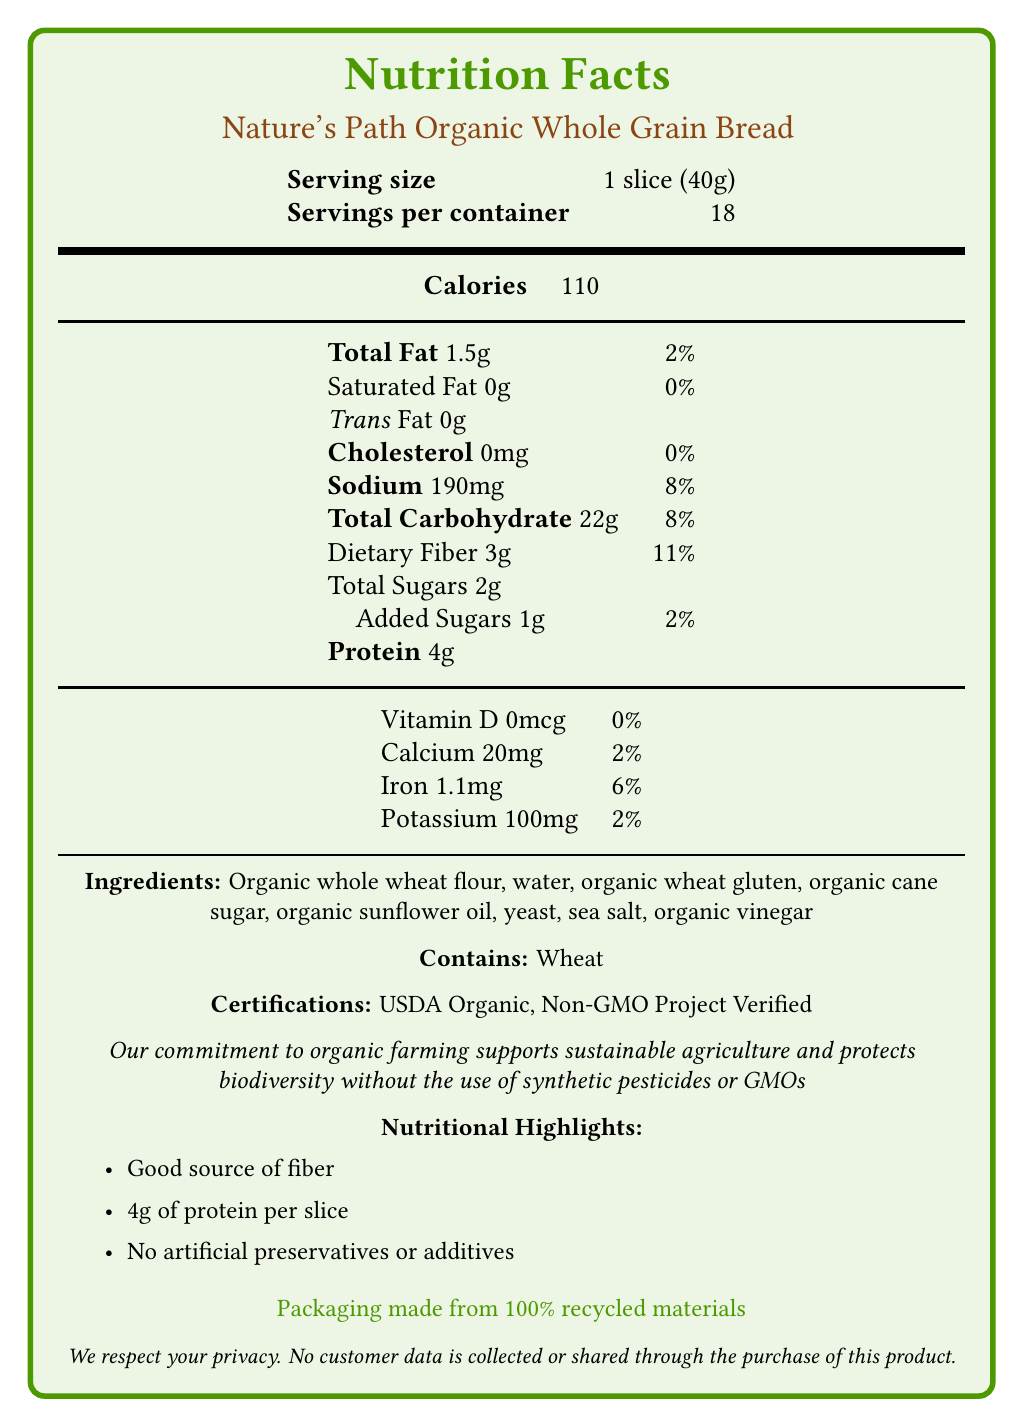what is the serving size? The serving size is listed as "1 slice (40g)" in the document.
Answer: 1 slice (40g) how much dietary fiber is in one slice? The document specifies that there are 3g of dietary fiber per serving.
Answer: 3g what percentage of the daily value of dietary fiber does one slice provide? The nutritional information indicates that one slice provides 11% of the daily value for dietary fiber.
Answer: 11% how many grams of protein are in one slice? The document states that one slice contains 4 grams of protein.
Answer: 4g what certifications does this bread have? The certifications listed in the document are USDA Organic and Non-GMO Project Verified.
Answer: USDA Organic, Non-GMO Project Verified is there any added sugar in the bread? The bread contains 1g of added sugars according to the nutritional information.
Answer: Yes does this bread contain any artificial preservatives or additives? The document highlights that the bread contains no artificial preservatives or additives.
Answer: No what is the total carbohydrate content per serving? A. 15g B. 20g C. 22g D. 25g The document lists the total carbohydrate content per serving as 22g.
Answer: C. 22g which of the following is NOT an ingredient in the bread? A. Organic whole wheat flour B. Organic cane sugar C. Organic almond flour D. Organic sunflower oil The ingredients listed do not include organic almond flour.
Answer: C. Organic almond flour does the bread contain any allergens? The document states that the bread contains wheat, which is an allergen.
Answer: Yes describe the main idea of the document The document presents the nutritional information for Nature's Path Organic Whole Grain Bread, including serving size, calories, macronutrient content, certifications, and other relevant details.
Answer: Nutrition facts for Nature's Path Organic Whole Grain Bread what is the environmental impact of the bread's packaging? The document indicates that the bread's packaging is made from 100% recycled materials.
Answer: Packaging made from 100% recycled materials how is the bread meant to be stored for maximum freshness? The storage instructions advise to keep the bread refrigerated and consume it within 7 days of opening.
Answer: Keep refrigerated and consume within 7 days of opening what organization manufactures this bread? The manufacturer of the bread is Nature's Path Foods, as stated in the document.
Answer: Nature's Path Foods how much calcium does one slice provide? The nutritional information lists the calcium content as 20mg per slice.
Answer: 20mg how many servings are there in one container? The document specifies that there are 18 servings per container.
Answer: 18 does the bread support sustainable agriculture? The ethical statement in the document explains that the bread supports sustainable agriculture and protects biodiversity by avoiding synthetic pesticides and GMOs.
Answer: Yes how much cholesterol is in one slice? The nutritional information indicates that there is 0mg of cholesterol per slice.
Answer: 0mg what is the main protein source in the bread? The document does not provide specific information on the source of protein in the bread.
Answer: Cannot be determined 